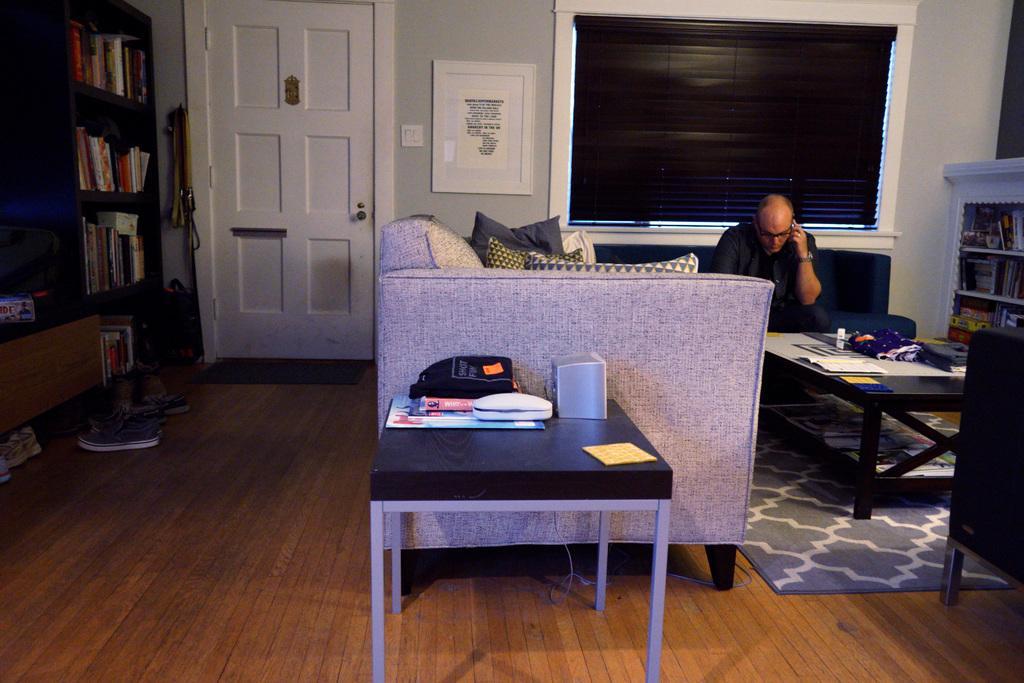Describe this image in one or two sentences. This picture shows a man seated on a sofa and he holds a mobile in his hand and we see a bookshelf and a door, shoes and a table and we see papers. 